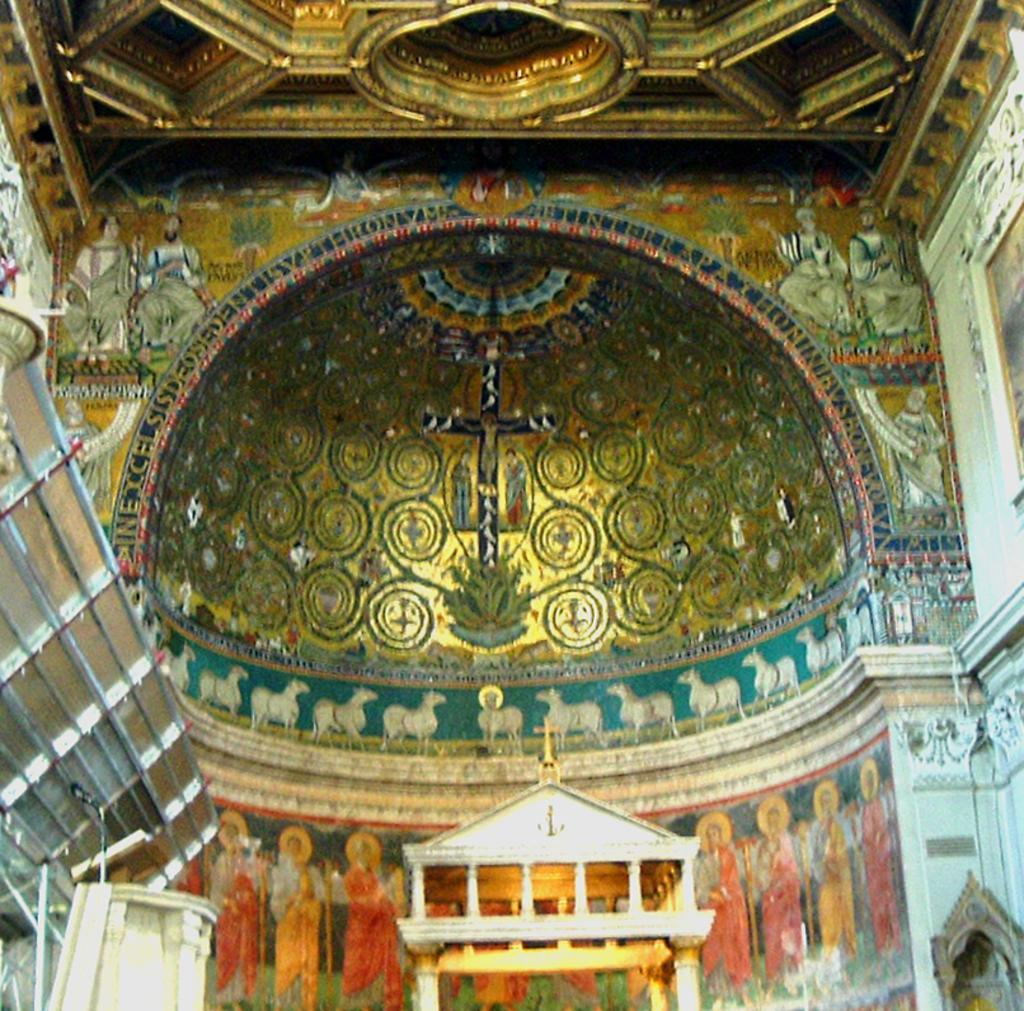How are the walls in the image decorated? The walls in the image are decorated. What about the ceiling in the image? The ceiling in the image is also decorated. Can you identify any specific symbols or images in the image? Yes, there is a cross symbol in the image. Are there any architectural features present in the image? Yes, there are pillars in the image. How does the growth of the plants affect the decoration of the walls in the image? There are no plants mentioned in the image, so it is not possible to determine how their growth might affect the decoration of the walls. 